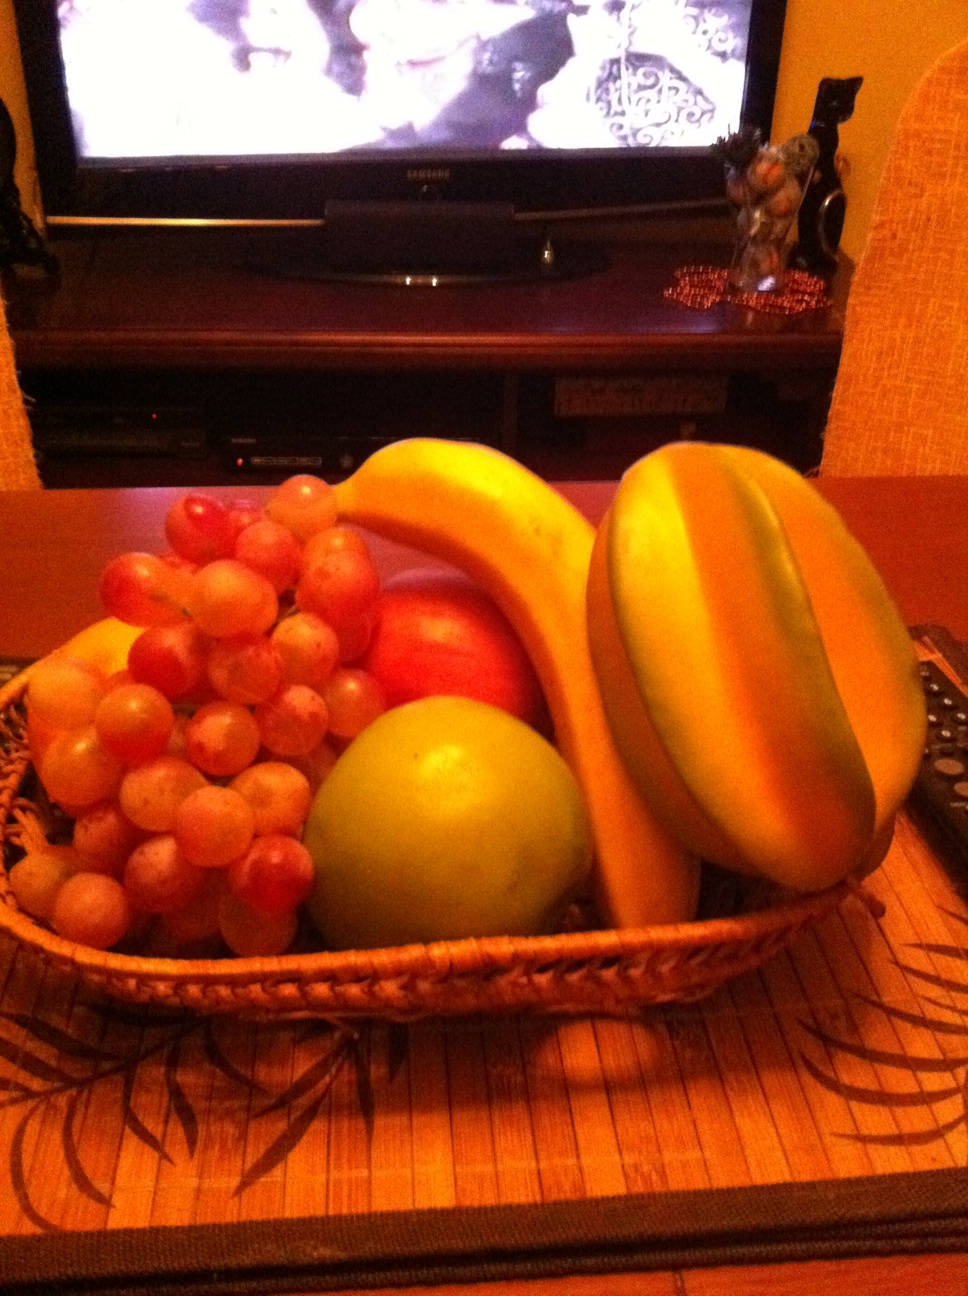What can you guess about the person who might own this fruit basket? Given the array of fresh, vibrant fruits carefully arranged in the basket, the owner likely values healthy eating. The cozy and neatly arranged setting suggests that this individual also enjoys creating a warm, welcoming living space. The choice of an intricate placemat and the visible television imply a comfort with home life and possibly an interest in entertainment or relaxation in familiar surroundings. What do these fruits suggest about the season or the owner's preferences? The fruits in the basket - bananas, apples, grapes, and a papaya - are generally available year-round but also suggest a preference for variety and flavor. This selection might hint at the owner's culinary versatility and a preference for incorporating fresh, natural foods into their diet, which could be a priority year-round. 